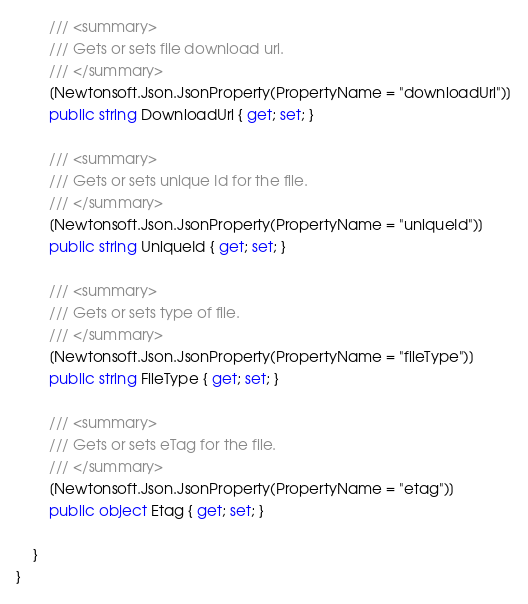Convert code to text. <code><loc_0><loc_0><loc_500><loc_500><_C#_>        /// <summary>
        /// Gets or sets file download url.
        /// </summary>
        [Newtonsoft.Json.JsonProperty(PropertyName = "downloadUrl")]
        public string DownloadUrl { get; set; }

        /// <summary>
        /// Gets or sets unique Id for the file.
        /// </summary>
        [Newtonsoft.Json.JsonProperty(PropertyName = "uniqueId")]
        public string UniqueId { get; set; }

        /// <summary>
        /// Gets or sets type of file.
        /// </summary>
        [Newtonsoft.Json.JsonProperty(PropertyName = "fileType")]
        public string FileType { get; set; }

        /// <summary>
        /// Gets or sets eTag for the file.
        /// </summary>
        [Newtonsoft.Json.JsonProperty(PropertyName = "etag")]
        public object Etag { get; set; }

    }
}
</code> 